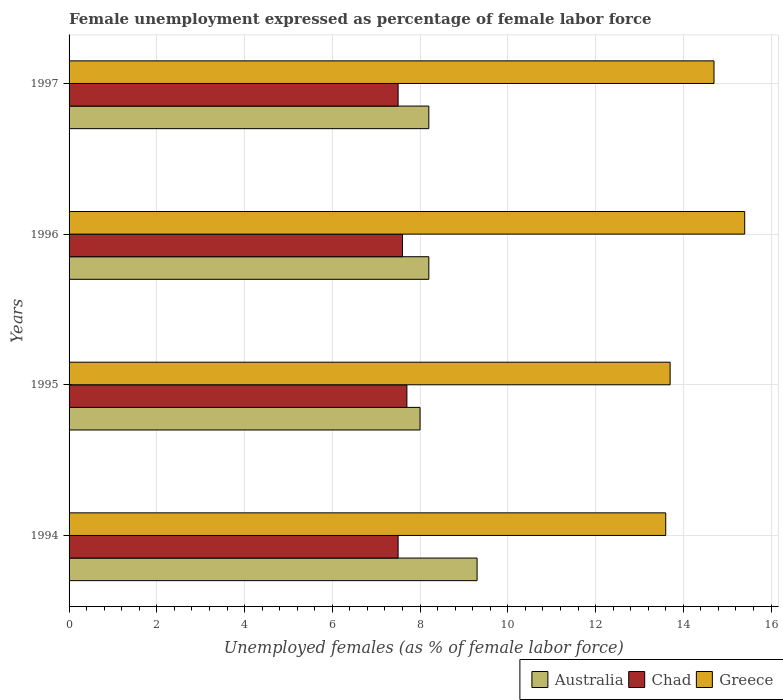How many different coloured bars are there?
Provide a short and direct response. 3. How many groups of bars are there?
Your answer should be very brief. 4. Are the number of bars per tick equal to the number of legend labels?
Offer a terse response. Yes. Are the number of bars on each tick of the Y-axis equal?
Give a very brief answer. Yes. How many bars are there on the 1st tick from the bottom?
Offer a terse response. 3. What is the label of the 2nd group of bars from the top?
Your answer should be very brief. 1996. What is the unemployment in females in in Greece in 1996?
Provide a short and direct response. 15.4. Across all years, what is the maximum unemployment in females in in Chad?
Make the answer very short. 7.7. Across all years, what is the minimum unemployment in females in in Greece?
Your answer should be compact. 13.6. In which year was the unemployment in females in in Chad maximum?
Your answer should be compact. 1995. What is the total unemployment in females in in Chad in the graph?
Your answer should be compact. 30.3. What is the difference between the unemployment in females in in Greece in 1996 and that in 1997?
Give a very brief answer. 0.7. What is the difference between the unemployment in females in in Greece in 1996 and the unemployment in females in in Australia in 1997?
Provide a succinct answer. 7.2. What is the average unemployment in females in in Greece per year?
Make the answer very short. 14.35. In the year 1995, what is the difference between the unemployment in females in in Greece and unemployment in females in in Chad?
Offer a terse response. 6. In how many years, is the unemployment in females in in Greece greater than 10 %?
Offer a terse response. 4. What is the ratio of the unemployment in females in in Greece in 1995 to that in 1997?
Your response must be concise. 0.93. What is the difference between the highest and the second highest unemployment in females in in Chad?
Your answer should be very brief. 0.1. What is the difference between the highest and the lowest unemployment in females in in Greece?
Ensure brevity in your answer.  1.8. In how many years, is the unemployment in females in in Australia greater than the average unemployment in females in in Australia taken over all years?
Ensure brevity in your answer.  1. Is the sum of the unemployment in females in in Chad in 1994 and 1997 greater than the maximum unemployment in females in in Australia across all years?
Offer a terse response. Yes. What does the 3rd bar from the bottom in 1997 represents?
Give a very brief answer. Greece. Is it the case that in every year, the sum of the unemployment in females in in Greece and unemployment in females in in Chad is greater than the unemployment in females in in Australia?
Your answer should be very brief. Yes. Are all the bars in the graph horizontal?
Make the answer very short. Yes. How many years are there in the graph?
Offer a terse response. 4. Does the graph contain any zero values?
Your answer should be very brief. No. Does the graph contain grids?
Your response must be concise. Yes. What is the title of the graph?
Provide a succinct answer. Female unemployment expressed as percentage of female labor force. Does "Saudi Arabia" appear as one of the legend labels in the graph?
Make the answer very short. No. What is the label or title of the X-axis?
Offer a terse response. Unemployed females (as % of female labor force). What is the Unemployed females (as % of female labor force) of Australia in 1994?
Your answer should be compact. 9.3. What is the Unemployed females (as % of female labor force) of Chad in 1994?
Ensure brevity in your answer.  7.5. What is the Unemployed females (as % of female labor force) in Greece in 1994?
Offer a very short reply. 13.6. What is the Unemployed females (as % of female labor force) of Chad in 1995?
Keep it short and to the point. 7.7. What is the Unemployed females (as % of female labor force) of Greece in 1995?
Keep it short and to the point. 13.7. What is the Unemployed females (as % of female labor force) in Australia in 1996?
Ensure brevity in your answer.  8.2. What is the Unemployed females (as % of female labor force) in Chad in 1996?
Offer a terse response. 7.6. What is the Unemployed females (as % of female labor force) in Greece in 1996?
Give a very brief answer. 15.4. What is the Unemployed females (as % of female labor force) in Australia in 1997?
Offer a terse response. 8.2. What is the Unemployed females (as % of female labor force) in Greece in 1997?
Your answer should be very brief. 14.7. Across all years, what is the maximum Unemployed females (as % of female labor force) in Australia?
Your answer should be compact. 9.3. Across all years, what is the maximum Unemployed females (as % of female labor force) of Chad?
Ensure brevity in your answer.  7.7. Across all years, what is the maximum Unemployed females (as % of female labor force) in Greece?
Offer a very short reply. 15.4. Across all years, what is the minimum Unemployed females (as % of female labor force) in Greece?
Keep it short and to the point. 13.6. What is the total Unemployed females (as % of female labor force) of Australia in the graph?
Your response must be concise. 33.7. What is the total Unemployed females (as % of female labor force) of Chad in the graph?
Make the answer very short. 30.3. What is the total Unemployed females (as % of female labor force) in Greece in the graph?
Provide a succinct answer. 57.4. What is the difference between the Unemployed females (as % of female labor force) in Australia in 1994 and that in 1995?
Your answer should be compact. 1.3. What is the difference between the Unemployed females (as % of female labor force) of Greece in 1994 and that in 1995?
Provide a short and direct response. -0.1. What is the difference between the Unemployed females (as % of female labor force) of Australia in 1994 and that in 1996?
Offer a very short reply. 1.1. What is the difference between the Unemployed females (as % of female labor force) in Australia in 1994 and that in 1997?
Keep it short and to the point. 1.1. What is the difference between the Unemployed females (as % of female labor force) of Chad in 1995 and that in 1996?
Offer a terse response. 0.1. What is the difference between the Unemployed females (as % of female labor force) in Australia in 1995 and that in 1997?
Offer a very short reply. -0.2. What is the difference between the Unemployed females (as % of female labor force) in Greece in 1995 and that in 1997?
Offer a terse response. -1. What is the difference between the Unemployed females (as % of female labor force) in Australia in 1996 and that in 1997?
Keep it short and to the point. 0. What is the difference between the Unemployed females (as % of female labor force) in Chad in 1994 and the Unemployed females (as % of female labor force) in Greece in 1995?
Provide a succinct answer. -6.2. What is the difference between the Unemployed females (as % of female labor force) of Australia in 1994 and the Unemployed females (as % of female labor force) of Greece in 1996?
Provide a succinct answer. -6.1. What is the difference between the Unemployed females (as % of female labor force) in Australia in 1994 and the Unemployed females (as % of female labor force) in Chad in 1997?
Give a very brief answer. 1.8. What is the difference between the Unemployed females (as % of female labor force) in Chad in 1994 and the Unemployed females (as % of female labor force) in Greece in 1997?
Keep it short and to the point. -7.2. What is the difference between the Unemployed females (as % of female labor force) in Australia in 1995 and the Unemployed females (as % of female labor force) in Chad in 1996?
Your answer should be very brief. 0.4. What is the difference between the Unemployed females (as % of female labor force) of Chad in 1995 and the Unemployed females (as % of female labor force) of Greece in 1996?
Offer a very short reply. -7.7. What is the difference between the Unemployed females (as % of female labor force) of Australia in 1995 and the Unemployed females (as % of female labor force) of Chad in 1997?
Provide a short and direct response. 0.5. What is the difference between the Unemployed females (as % of female labor force) in Australia in 1995 and the Unemployed females (as % of female labor force) in Greece in 1997?
Provide a short and direct response. -6.7. What is the difference between the Unemployed females (as % of female labor force) in Australia in 1996 and the Unemployed females (as % of female labor force) in Greece in 1997?
Provide a succinct answer. -6.5. What is the average Unemployed females (as % of female labor force) of Australia per year?
Ensure brevity in your answer.  8.43. What is the average Unemployed females (as % of female labor force) of Chad per year?
Give a very brief answer. 7.58. What is the average Unemployed females (as % of female labor force) of Greece per year?
Give a very brief answer. 14.35. In the year 1994, what is the difference between the Unemployed females (as % of female labor force) in Chad and Unemployed females (as % of female labor force) in Greece?
Your answer should be compact. -6.1. In the year 1995, what is the difference between the Unemployed females (as % of female labor force) in Australia and Unemployed females (as % of female labor force) in Chad?
Your answer should be compact. 0.3. In the year 1995, what is the difference between the Unemployed females (as % of female labor force) in Australia and Unemployed females (as % of female labor force) in Greece?
Offer a very short reply. -5.7. In the year 1996, what is the difference between the Unemployed females (as % of female labor force) of Australia and Unemployed females (as % of female labor force) of Chad?
Offer a very short reply. 0.6. In the year 1997, what is the difference between the Unemployed females (as % of female labor force) of Australia and Unemployed females (as % of female labor force) of Chad?
Keep it short and to the point. 0.7. In the year 1997, what is the difference between the Unemployed females (as % of female labor force) in Australia and Unemployed females (as % of female labor force) in Greece?
Make the answer very short. -6.5. In the year 1997, what is the difference between the Unemployed females (as % of female labor force) in Chad and Unemployed females (as % of female labor force) in Greece?
Provide a short and direct response. -7.2. What is the ratio of the Unemployed females (as % of female labor force) in Australia in 1994 to that in 1995?
Offer a very short reply. 1.16. What is the ratio of the Unemployed females (as % of female labor force) of Chad in 1994 to that in 1995?
Your answer should be compact. 0.97. What is the ratio of the Unemployed females (as % of female labor force) of Greece in 1994 to that in 1995?
Your response must be concise. 0.99. What is the ratio of the Unemployed females (as % of female labor force) in Australia in 1994 to that in 1996?
Provide a short and direct response. 1.13. What is the ratio of the Unemployed females (as % of female labor force) in Chad in 1994 to that in 1996?
Offer a terse response. 0.99. What is the ratio of the Unemployed females (as % of female labor force) of Greece in 1994 to that in 1996?
Offer a terse response. 0.88. What is the ratio of the Unemployed females (as % of female labor force) of Australia in 1994 to that in 1997?
Offer a very short reply. 1.13. What is the ratio of the Unemployed females (as % of female labor force) of Chad in 1994 to that in 1997?
Your answer should be compact. 1. What is the ratio of the Unemployed females (as % of female labor force) of Greece in 1994 to that in 1997?
Your answer should be compact. 0.93. What is the ratio of the Unemployed females (as % of female labor force) of Australia in 1995 to that in 1996?
Your answer should be very brief. 0.98. What is the ratio of the Unemployed females (as % of female labor force) in Chad in 1995 to that in 1996?
Your answer should be very brief. 1.01. What is the ratio of the Unemployed females (as % of female labor force) in Greece in 1995 to that in 1996?
Your response must be concise. 0.89. What is the ratio of the Unemployed females (as % of female labor force) in Australia in 1995 to that in 1997?
Keep it short and to the point. 0.98. What is the ratio of the Unemployed females (as % of female labor force) in Chad in 1995 to that in 1997?
Provide a short and direct response. 1.03. What is the ratio of the Unemployed females (as % of female labor force) of Greece in 1995 to that in 1997?
Offer a terse response. 0.93. What is the ratio of the Unemployed females (as % of female labor force) in Chad in 1996 to that in 1997?
Keep it short and to the point. 1.01. What is the ratio of the Unemployed females (as % of female labor force) of Greece in 1996 to that in 1997?
Offer a very short reply. 1.05. What is the difference between the highest and the second highest Unemployed females (as % of female labor force) in Australia?
Offer a very short reply. 1.1. What is the difference between the highest and the lowest Unemployed females (as % of female labor force) in Australia?
Provide a succinct answer. 1.3. What is the difference between the highest and the lowest Unemployed females (as % of female labor force) of Greece?
Provide a succinct answer. 1.8. 